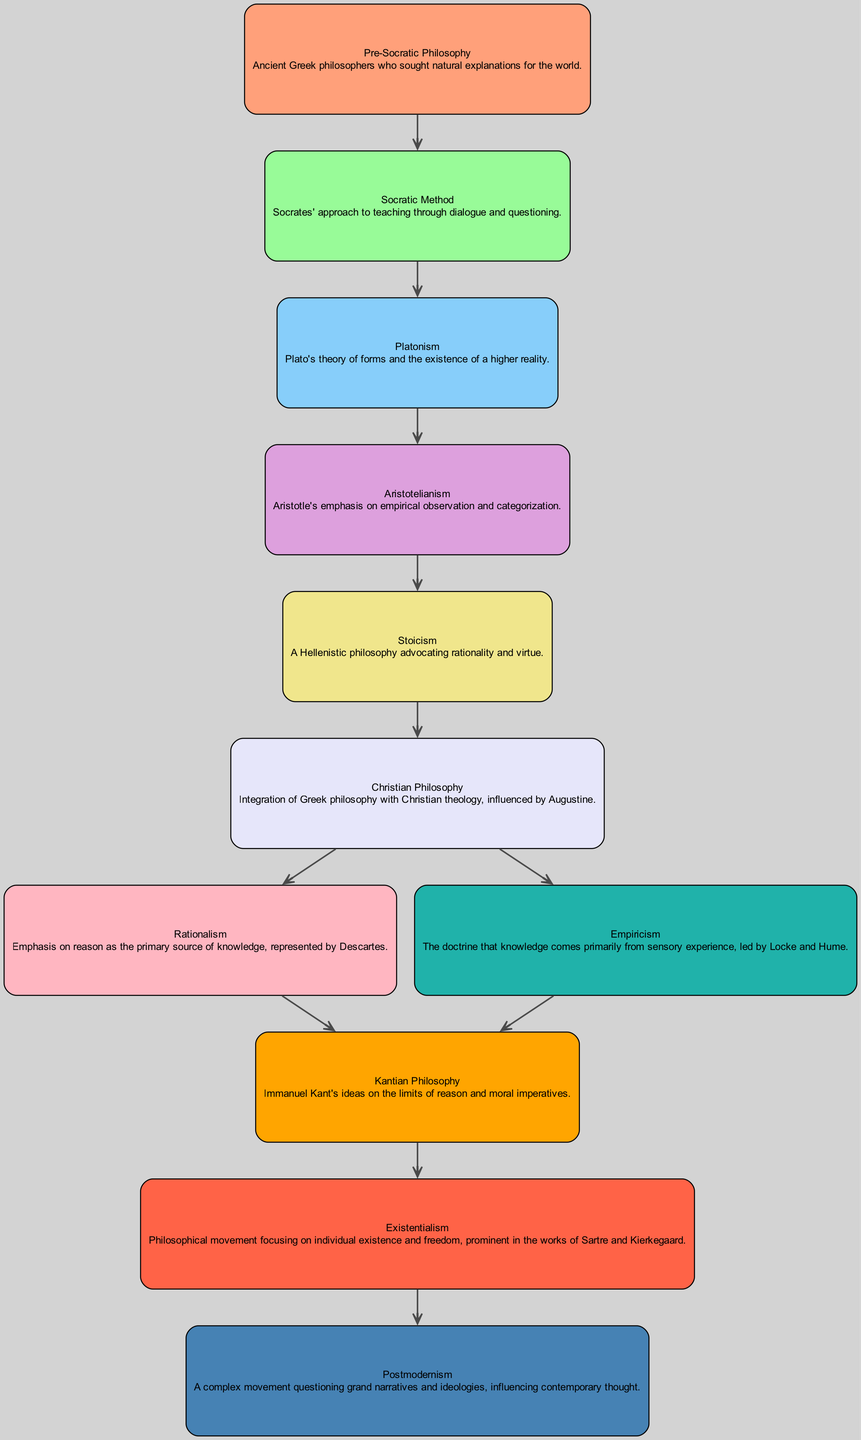What is the first philosophical movement in the diagram? The diagram begins with "Pre-Socratic Philosophy," which is the first node listed.
Answer: Pre-Socratic Philosophy How many edges are present in the diagram? Counting the connections between the nodes, there are a total of 10 edges linking the various philosophical movements.
Answer: 10 What philosophy directly follows Aristotelianism? The node that comes immediately after "Aristotelianism" in the directed graph is "Stoicism."
Answer: Stoicism Which two philosophies emerge from Christian Philosophy? From "Christian Philosophy," the diagram shows two splits leading to "Rationalism" and "Empiricism," indicating these two philosophies emerged from it.
Answer: Rationalism and Empiricism What is the relationship between Rationalism and Kantian Philosophy? The directed edge indicates that Rationalism leads to Kantian Philosophy, establishing a direct influence between the two.
Answer: Rationalism leads to Kantian Philosophy How many nodes focus on the theme of individual existence and freedom? By analyzing the diagram, "Existentialism" is the only node that centers on the theme of individual existence and freedom.
Answer: 1 Which philosophical school of thought questions grand narratives? The last node in the graph, "Postmodernism," is the movement that is known for questioning grand narratives and ideologies.
Answer: Postmodernism What connects Stoicism and Christian Philosophy in the diagram? The connection is established through an edge that shows Stoicism leading to Christian Philosophy, suggesting Stoicism influenced it.
Answer: Stoicism influences Christian Philosophy What is the last philosophical movement depicted in the diagram? The diagram concludes with "Postmodernism," which is the final node in the sequence of philosophical movements.
Answer: Postmodernism Which philosophy emphasizes sensory experience as the primary source of knowledge? "Empiricism" is the philosophy noted for emphasizing sensory experience as the main source of knowledge.
Answer: Empiricism 